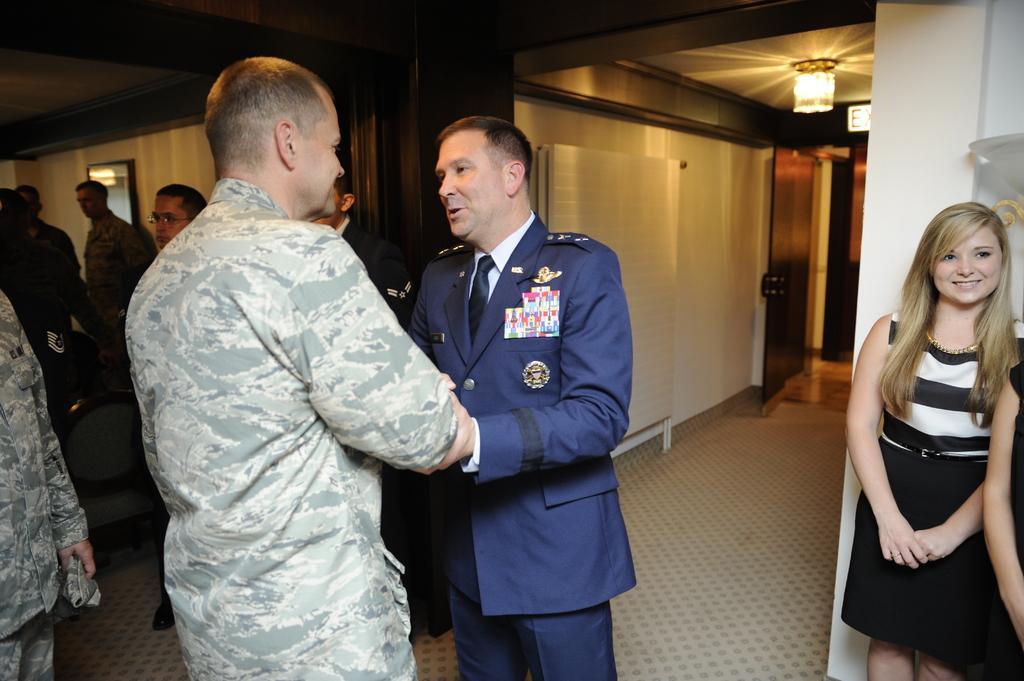Please provide a concise description of this image. Here men and women are standing, this is light and wall. 